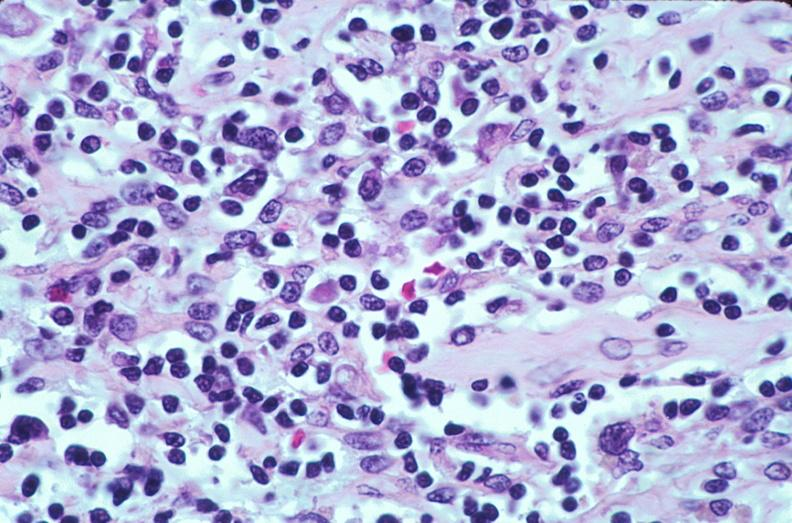does this image show lymph nodes, nodular sclerosing hodgkins disease?
Answer the question using a single word or phrase. Yes 